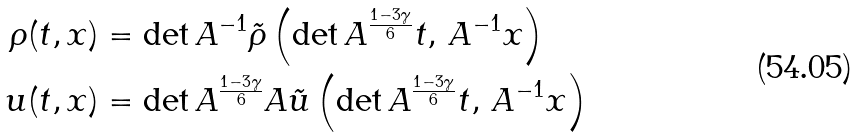Convert formula to latex. <formula><loc_0><loc_0><loc_500><loc_500>\rho ( t , x ) & = \det A ^ { - 1 } \tilde { \rho } \left ( \det A ^ { \frac { 1 - 3 \gamma } { 6 } } t , \, A ^ { - 1 } x \right ) \\ { u } ( t , x ) & = \det A ^ { \frac { 1 - 3 \gamma } { 6 } } A \tilde { u } \left ( \det A ^ { \frac { 1 - 3 \gamma } { 6 } } t , \, A ^ { - 1 } x \right )</formula> 